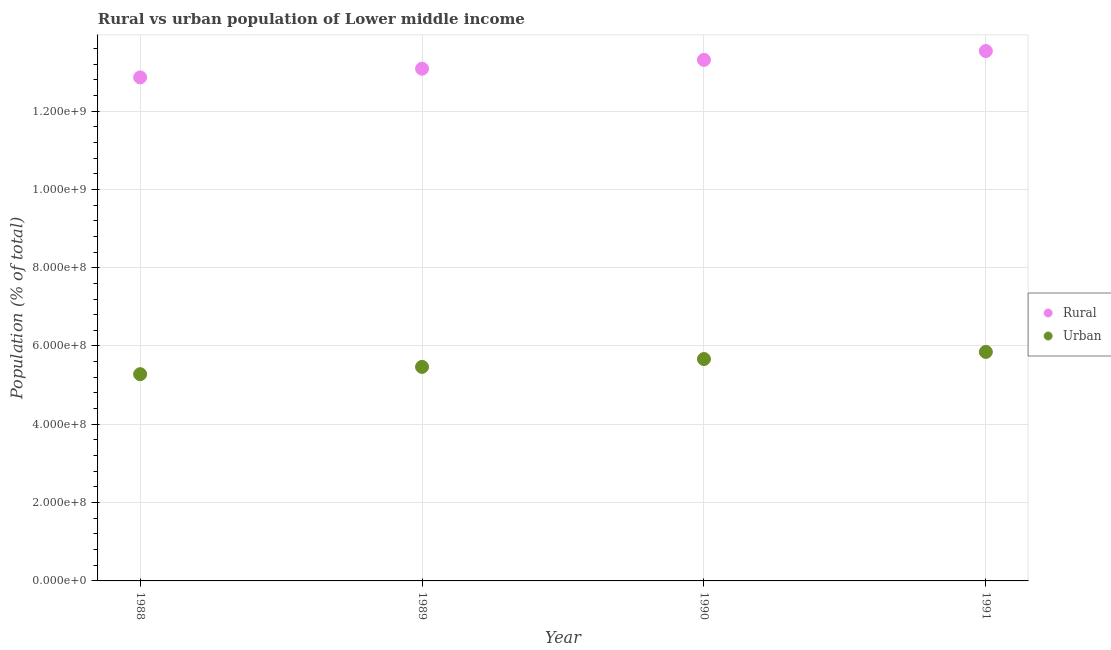What is the rural population density in 1988?
Your answer should be compact. 1.29e+09. Across all years, what is the maximum rural population density?
Keep it short and to the point. 1.35e+09. Across all years, what is the minimum rural population density?
Your answer should be compact. 1.29e+09. What is the total rural population density in the graph?
Ensure brevity in your answer.  5.28e+09. What is the difference between the urban population density in 1988 and that in 1990?
Keep it short and to the point. -3.87e+07. What is the difference between the urban population density in 1989 and the rural population density in 1991?
Your answer should be very brief. -8.07e+08. What is the average urban population density per year?
Offer a very short reply. 5.57e+08. In the year 1991, what is the difference between the urban population density and rural population density?
Make the answer very short. -7.68e+08. In how many years, is the rural population density greater than 200000000 %?
Offer a terse response. 4. What is the ratio of the rural population density in 1990 to that in 1991?
Keep it short and to the point. 0.98. Is the difference between the urban population density in 1988 and 1989 greater than the difference between the rural population density in 1988 and 1989?
Your answer should be compact. Yes. What is the difference between the highest and the second highest rural population density?
Offer a terse response. 2.26e+07. What is the difference between the highest and the lowest urban population density?
Make the answer very short. 5.69e+07. Does the urban population density monotonically increase over the years?
Your answer should be very brief. Yes. Are the values on the major ticks of Y-axis written in scientific E-notation?
Your answer should be compact. Yes. Does the graph contain any zero values?
Your response must be concise. No. Where does the legend appear in the graph?
Ensure brevity in your answer.  Center right. What is the title of the graph?
Your answer should be very brief. Rural vs urban population of Lower middle income. What is the label or title of the Y-axis?
Your response must be concise. Population (% of total). What is the Population (% of total) of Rural in 1988?
Offer a terse response. 1.29e+09. What is the Population (% of total) of Urban in 1988?
Offer a very short reply. 5.28e+08. What is the Population (% of total) of Rural in 1989?
Offer a very short reply. 1.31e+09. What is the Population (% of total) in Urban in 1989?
Offer a very short reply. 5.47e+08. What is the Population (% of total) in Rural in 1990?
Provide a succinct answer. 1.33e+09. What is the Population (% of total) in Urban in 1990?
Make the answer very short. 5.67e+08. What is the Population (% of total) in Rural in 1991?
Ensure brevity in your answer.  1.35e+09. What is the Population (% of total) of Urban in 1991?
Provide a succinct answer. 5.85e+08. Across all years, what is the maximum Population (% of total) in Rural?
Ensure brevity in your answer.  1.35e+09. Across all years, what is the maximum Population (% of total) of Urban?
Your answer should be very brief. 5.85e+08. Across all years, what is the minimum Population (% of total) in Rural?
Keep it short and to the point. 1.29e+09. Across all years, what is the minimum Population (% of total) of Urban?
Your response must be concise. 5.28e+08. What is the total Population (% of total) of Rural in the graph?
Ensure brevity in your answer.  5.28e+09. What is the total Population (% of total) in Urban in the graph?
Offer a terse response. 2.23e+09. What is the difference between the Population (% of total) of Rural in 1988 and that in 1989?
Provide a short and direct response. -2.23e+07. What is the difference between the Population (% of total) of Urban in 1988 and that in 1989?
Make the answer very short. -1.87e+07. What is the difference between the Population (% of total) of Rural in 1988 and that in 1990?
Give a very brief answer. -4.47e+07. What is the difference between the Population (% of total) in Urban in 1988 and that in 1990?
Make the answer very short. -3.87e+07. What is the difference between the Population (% of total) in Rural in 1988 and that in 1991?
Make the answer very short. -6.73e+07. What is the difference between the Population (% of total) in Urban in 1988 and that in 1991?
Provide a succinct answer. -5.69e+07. What is the difference between the Population (% of total) of Rural in 1989 and that in 1990?
Offer a very short reply. -2.25e+07. What is the difference between the Population (% of total) in Urban in 1989 and that in 1990?
Give a very brief answer. -2.01e+07. What is the difference between the Population (% of total) of Rural in 1989 and that in 1991?
Give a very brief answer. -4.51e+07. What is the difference between the Population (% of total) in Urban in 1989 and that in 1991?
Give a very brief answer. -3.82e+07. What is the difference between the Population (% of total) in Rural in 1990 and that in 1991?
Offer a terse response. -2.26e+07. What is the difference between the Population (% of total) of Urban in 1990 and that in 1991?
Ensure brevity in your answer.  -1.82e+07. What is the difference between the Population (% of total) of Rural in 1988 and the Population (% of total) of Urban in 1989?
Provide a short and direct response. 7.39e+08. What is the difference between the Population (% of total) in Rural in 1988 and the Population (% of total) in Urban in 1990?
Give a very brief answer. 7.19e+08. What is the difference between the Population (% of total) in Rural in 1988 and the Population (% of total) in Urban in 1991?
Ensure brevity in your answer.  7.01e+08. What is the difference between the Population (% of total) in Rural in 1989 and the Population (% of total) in Urban in 1990?
Your answer should be very brief. 7.42e+08. What is the difference between the Population (% of total) of Rural in 1989 and the Population (% of total) of Urban in 1991?
Your answer should be very brief. 7.23e+08. What is the difference between the Population (% of total) of Rural in 1990 and the Population (% of total) of Urban in 1991?
Your answer should be compact. 7.46e+08. What is the average Population (% of total) in Rural per year?
Your answer should be compact. 1.32e+09. What is the average Population (% of total) in Urban per year?
Your answer should be very brief. 5.57e+08. In the year 1988, what is the difference between the Population (% of total) in Rural and Population (% of total) in Urban?
Ensure brevity in your answer.  7.58e+08. In the year 1989, what is the difference between the Population (% of total) of Rural and Population (% of total) of Urban?
Provide a succinct answer. 7.62e+08. In the year 1990, what is the difference between the Population (% of total) in Rural and Population (% of total) in Urban?
Make the answer very short. 7.64e+08. In the year 1991, what is the difference between the Population (% of total) in Rural and Population (% of total) in Urban?
Give a very brief answer. 7.68e+08. What is the ratio of the Population (% of total) of Urban in 1988 to that in 1989?
Provide a short and direct response. 0.97. What is the ratio of the Population (% of total) of Rural in 1988 to that in 1990?
Give a very brief answer. 0.97. What is the ratio of the Population (% of total) of Urban in 1988 to that in 1990?
Offer a very short reply. 0.93. What is the ratio of the Population (% of total) of Rural in 1988 to that in 1991?
Provide a short and direct response. 0.95. What is the ratio of the Population (% of total) in Urban in 1988 to that in 1991?
Your answer should be compact. 0.9. What is the ratio of the Population (% of total) of Rural in 1989 to that in 1990?
Provide a succinct answer. 0.98. What is the ratio of the Population (% of total) in Urban in 1989 to that in 1990?
Your answer should be compact. 0.96. What is the ratio of the Population (% of total) in Rural in 1989 to that in 1991?
Keep it short and to the point. 0.97. What is the ratio of the Population (% of total) in Urban in 1989 to that in 1991?
Make the answer very short. 0.93. What is the ratio of the Population (% of total) of Rural in 1990 to that in 1991?
Ensure brevity in your answer.  0.98. What is the ratio of the Population (% of total) of Urban in 1990 to that in 1991?
Ensure brevity in your answer.  0.97. What is the difference between the highest and the second highest Population (% of total) of Rural?
Make the answer very short. 2.26e+07. What is the difference between the highest and the second highest Population (% of total) in Urban?
Ensure brevity in your answer.  1.82e+07. What is the difference between the highest and the lowest Population (% of total) of Rural?
Keep it short and to the point. 6.73e+07. What is the difference between the highest and the lowest Population (% of total) of Urban?
Your response must be concise. 5.69e+07. 